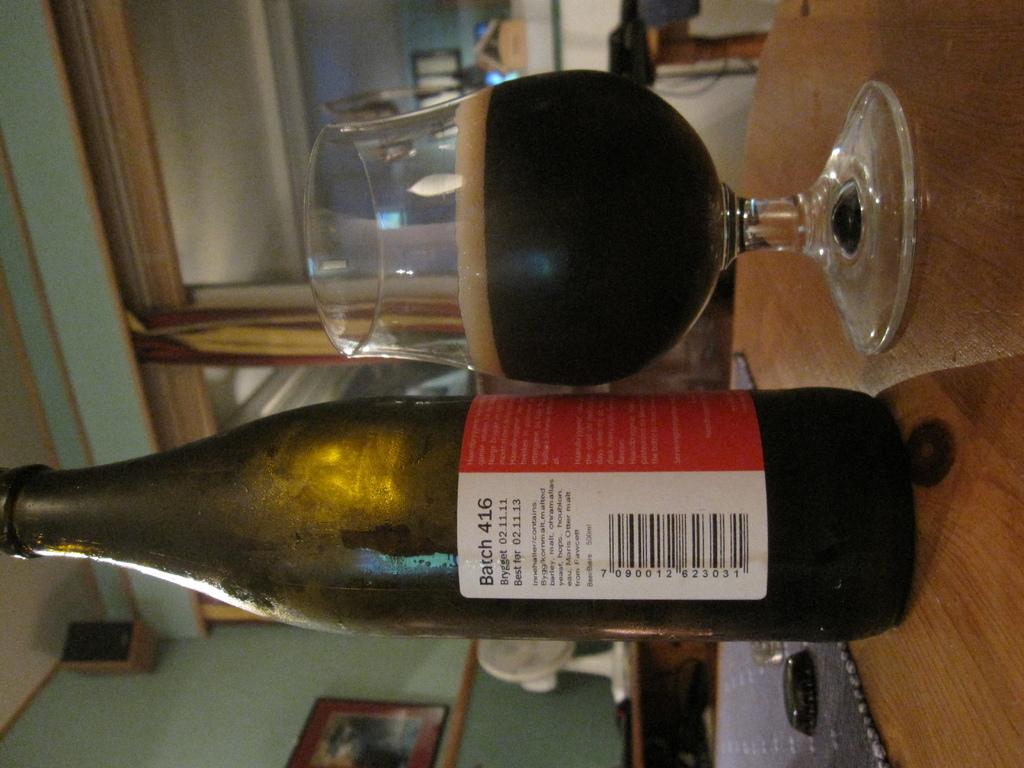What is the upc code?
Keep it short and to the point. 7090012623031. 